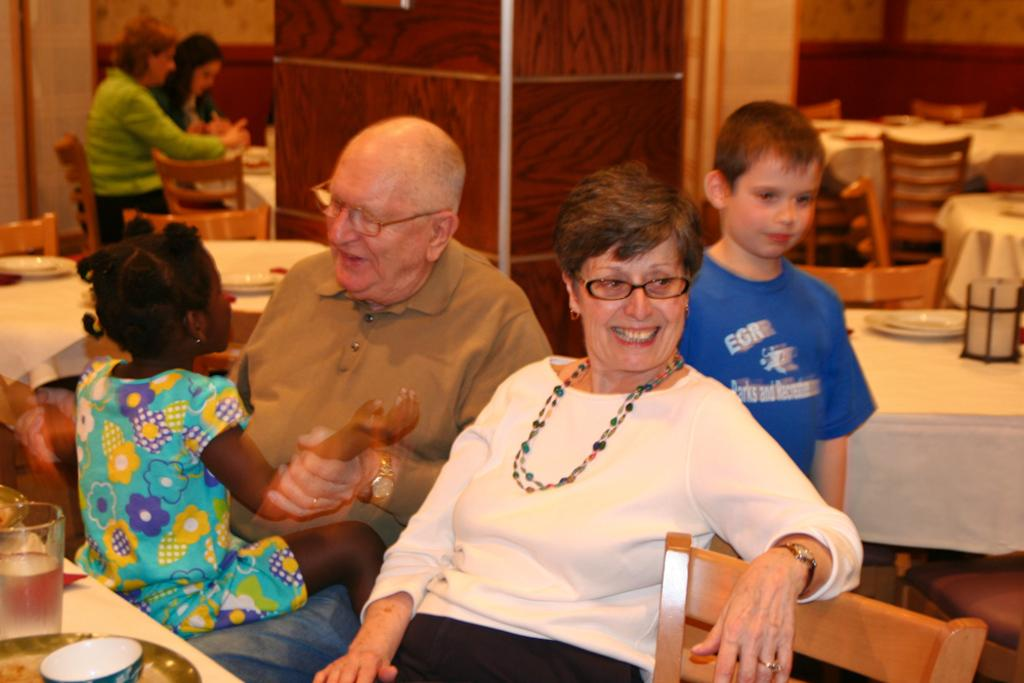How many people are in the image? There are four people in the image: a man, a woman, a boy, and a girl. What are the man and woman doing in the image? The man and woman are sitting on a chair together. Where is the boy positioned in relation to the woman? The boy is standing behind the woman. Who is the girl sitting on in the image? The girl is sitting on someone's lap. What type of yarn is the man using to create a loss in the image? There is no yarn or loss present in the image; it features a man, a woman, a boy, and a girl in various positions. 